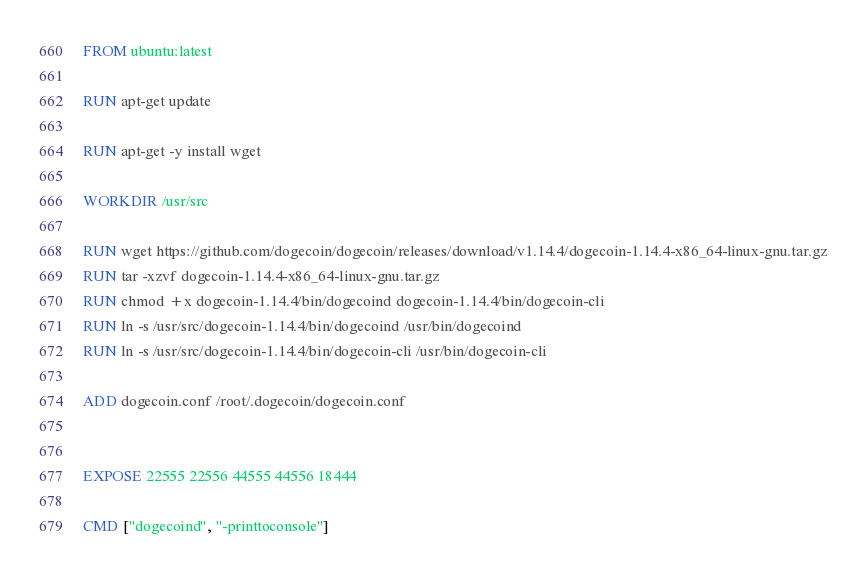Convert code to text. <code><loc_0><loc_0><loc_500><loc_500><_Dockerfile_>FROM ubuntu:latest

RUN apt-get update

RUN apt-get -y install wget

WORKDIR /usr/src

RUN wget https://github.com/dogecoin/dogecoin/releases/download/v1.14.4/dogecoin-1.14.4-x86_64-linux-gnu.tar.gz
RUN tar -xzvf dogecoin-1.14.4-x86_64-linux-gnu.tar.gz
RUN chmod +x dogecoin-1.14.4/bin/dogecoind dogecoin-1.14.4/bin/dogecoin-cli
RUN ln -s /usr/src/dogecoin-1.14.4/bin/dogecoind /usr/bin/dogecoind
RUN ln -s /usr/src/dogecoin-1.14.4/bin/dogecoin-cli /usr/bin/dogecoin-cli

ADD dogecoin.conf /root/.dogecoin/dogecoin.conf


EXPOSE 22555 22556 44555 44556 18444

CMD ["dogecoind", "-printtoconsole"]
</code> 